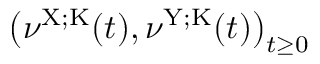Convert formula to latex. <formula><loc_0><loc_0><loc_500><loc_500>\left ( \nu ^ { X ; K } ( t ) , \nu ^ { Y ; K } ( t ) \right ) _ { t \geq 0 }</formula> 